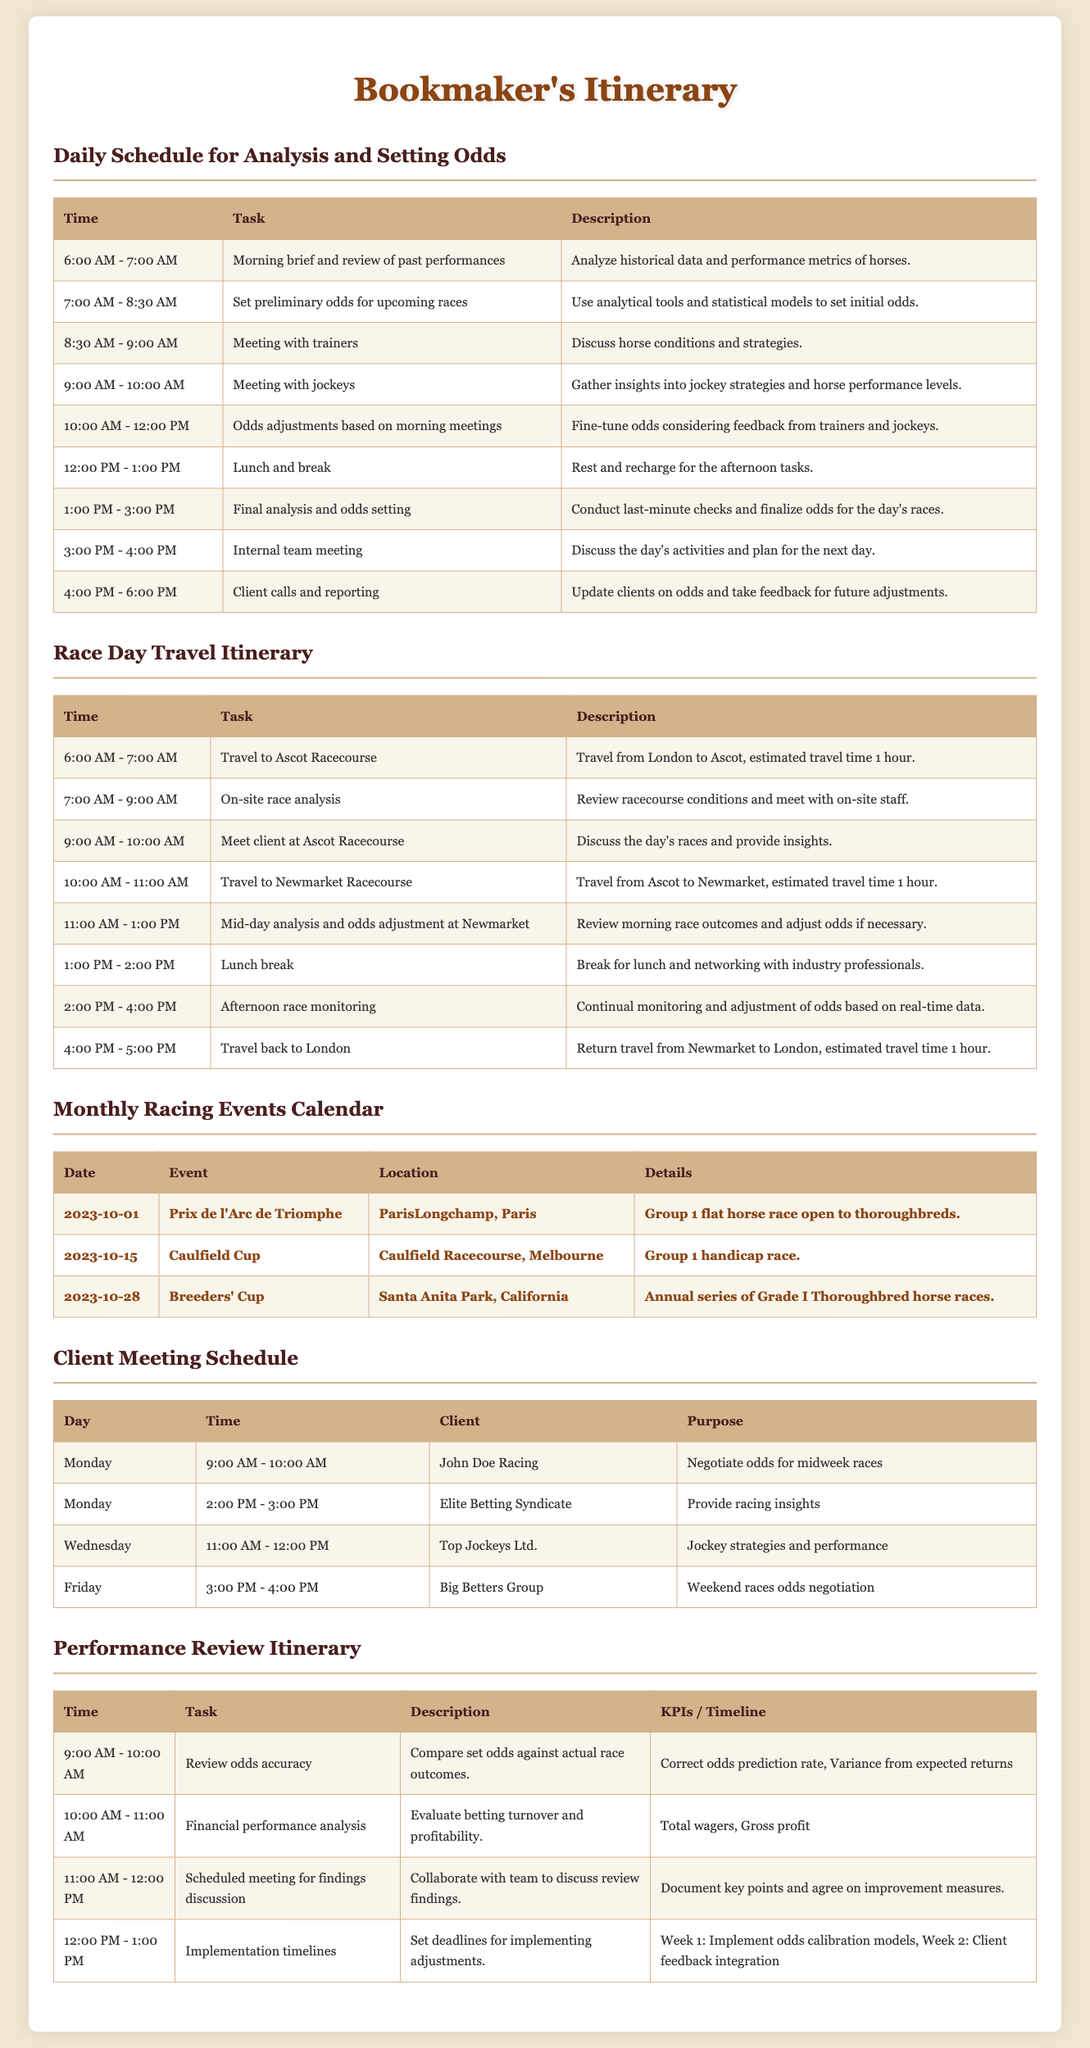What time does the daily schedule begin? The daily schedule begins at 6:00 AM, as indicated in the first task.
Answer: 6:00 AM What is the purpose of the meeting with jockeys? The purpose of the meeting with jockeys is to gather insights into jockey strategies and horse performance levels.
Answer: Insights into jockey strategies and horse performance levels How long is the travel time to Ascot Racecourse? The estimated travel time to Ascot Racecourse is mentioned as 1 hour.
Answer: 1 hour When is the Breeders' Cup scheduled? The Breeders' Cup is scheduled for October 28, 2023, as listed in the monthly events calendar.
Answer: 2023-10-28 What is one KPI used for reviewing odds accuracy? One KPI used for reviewing odds accuracy is the correct odds prediction rate, mentioned in the performance review itinerary.
Answer: Correct odds prediction rate What is the main task during the internal team meeting? The main task during the internal team meeting is to discuss the day's activities and plan for the next day.
Answer: Discuss the day's activities and plan for the next day How many client meetings are scheduled for Monday? There are two client meetings scheduled for Monday, as per the client meeting schedule.
Answer: Two meetings What is the next step after discussing review findings? The next step after discussing review findings is to set deadlines for implementing adjustments.
Answer: Set deadlines for implementing adjustments What is the primary focus of the mid-day analysis at Newmarket? The primary focus of the mid-day analysis at Newmarket is to review morning race outcomes and adjust odds if necessary.
Answer: Review morning race outcomes and adjust odds if necessary 